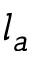Convert formula to latex. <formula><loc_0><loc_0><loc_500><loc_500>l _ { a }</formula> 